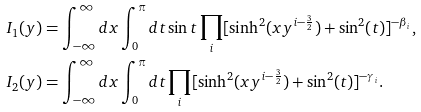<formula> <loc_0><loc_0><loc_500><loc_500>I _ { 1 } ( y ) & = \int _ { - \infty } ^ { \infty } d x \int _ { 0 } ^ { \pi } d t \sin t \prod _ { i } [ \sinh ^ { 2 } ( x y ^ { i - \frac { 3 } { 2 } } ) + \sin ^ { 2 } ( t ) ] ^ { - \beta _ { i } } , \\ I _ { 2 } ( y ) & = \int _ { - \infty } ^ { \infty } d x \int _ { 0 } ^ { \pi } d t \prod _ { i } [ \sinh ^ { 2 } ( x y ^ { i - \frac { 3 } { 2 } } ) + \sin ^ { 2 } ( t ) ] ^ { - \gamma _ { i } } .</formula> 